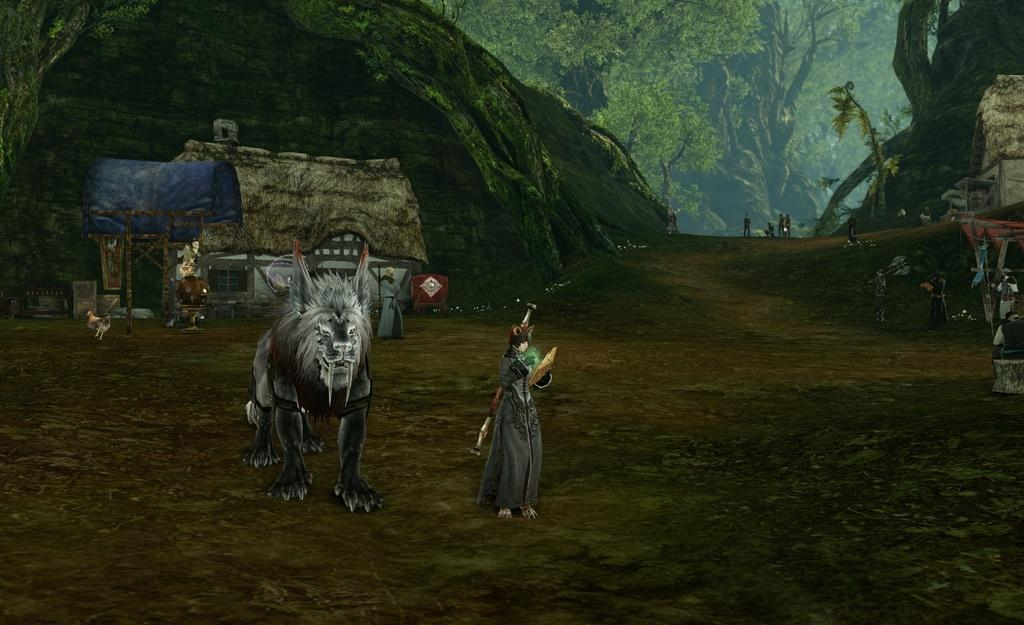What type of animal is present in the animation? There is an animal in the animation, but its specific type is not mentioned in the facts. What other living creature can be seen in the animation? There is a bird in the animation. Who or what else is present in the animation? There are people in the animation. What kind of natural features are visible in the animation? There are hills and trees in the animation. What type of structures can be seen in the animation? There are sheds in the animation. Are there any other objects or elements in the animation? Yes, there are other objects in the animation. What is the base of the animation's setting? There is ground at the bottom of the animation. What type of prose is being recited by the company during the dinner scene in the animation? There is no mention of a dinner scene or company in the animation, nor is there any reference to prose being recited. 